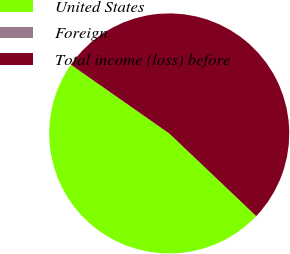Convert chart to OTSL. <chart><loc_0><loc_0><loc_500><loc_500><pie_chart><fcel>United States<fcel>Foreign<fcel>Total income (loss) before<nl><fcel>47.61%<fcel>0.01%<fcel>52.38%<nl></chart> 